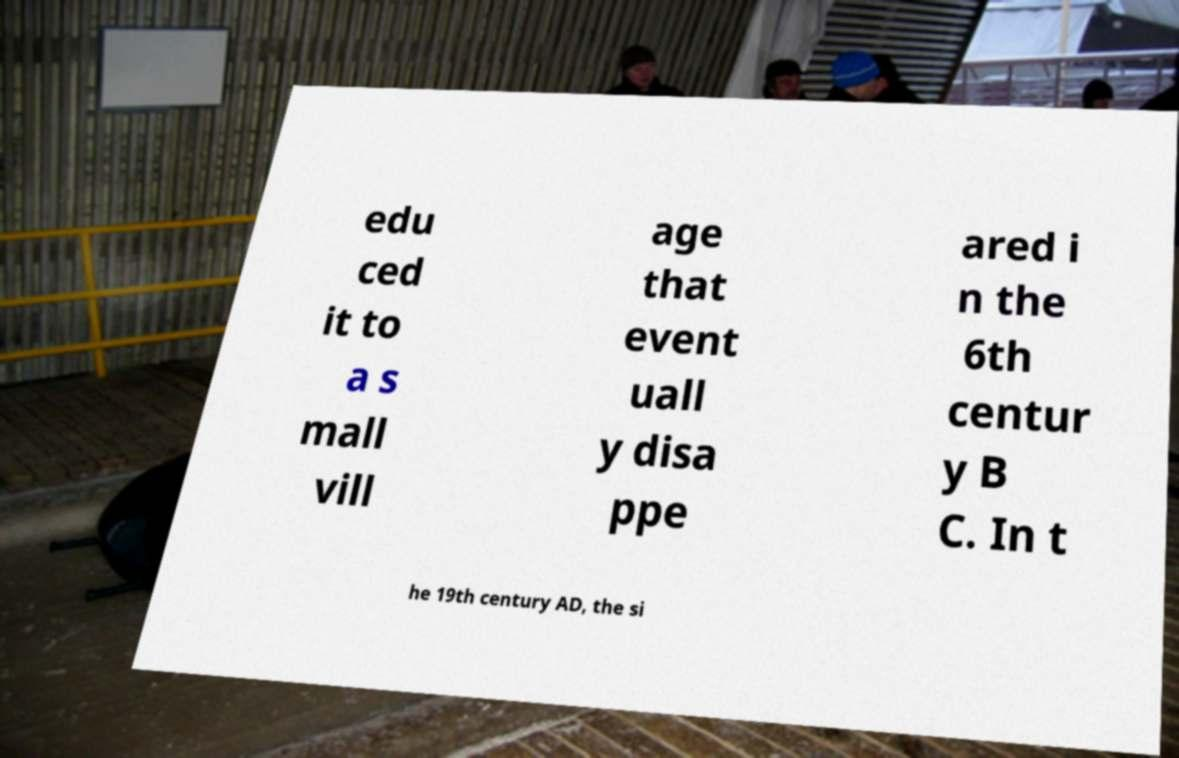There's text embedded in this image that I need extracted. Can you transcribe it verbatim? edu ced it to a s mall vill age that event uall y disa ppe ared i n the 6th centur y B C. In t he 19th century AD, the si 